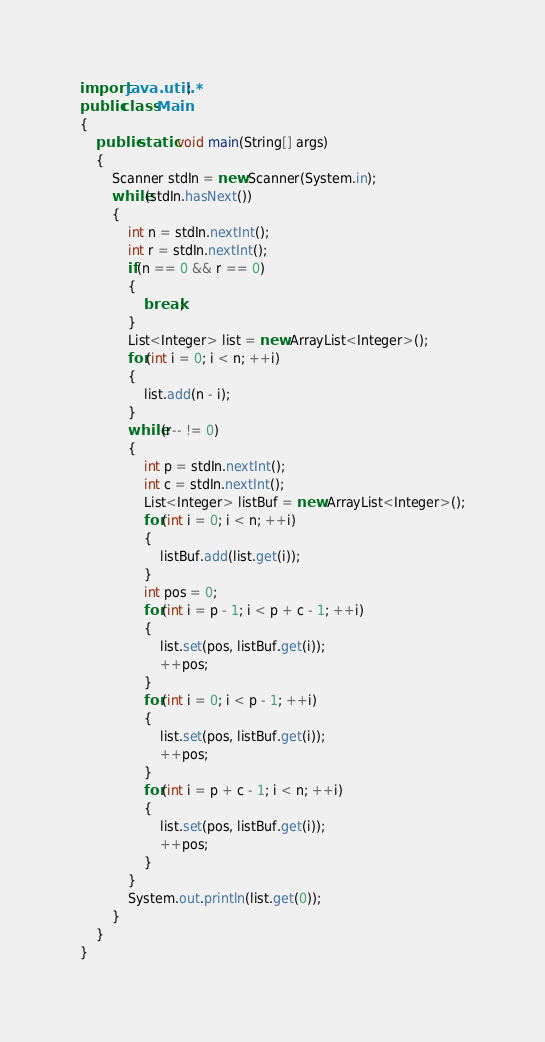<code> <loc_0><loc_0><loc_500><loc_500><_Java_>import java.util.*;
public class Main 
{
	public static void main(String[] args) 
	{
		Scanner stdIn = new Scanner(System.in);
		while(stdIn.hasNext())
		{
			int n = stdIn.nextInt();
			int r = stdIn.nextInt();
			if(n == 0 && r == 0)
			{
				break;
			}
			List<Integer> list = new ArrayList<Integer>();
			for(int i = 0; i < n; ++i)
			{
				list.add(n - i);
			}
			while(r-- != 0)
			{
				int p = stdIn.nextInt();
				int c = stdIn.nextInt();
				List<Integer> listBuf = new ArrayList<Integer>();
				for(int i = 0; i < n; ++i)
				{
					listBuf.add(list.get(i));
				}
				int pos = 0;
				for(int i = p - 1; i < p + c - 1; ++i)
				{
					list.set(pos, listBuf.get(i));
					++pos;
				}
				for(int i = 0; i < p - 1; ++i)
				{
					list.set(pos, listBuf.get(i));
					++pos;
				}
				for(int i = p + c - 1; i < n; ++i)
				{
					list.set(pos, listBuf.get(i));
					++pos;
				}
			}
			System.out.println(list.get(0));
		}
	}
}</code> 